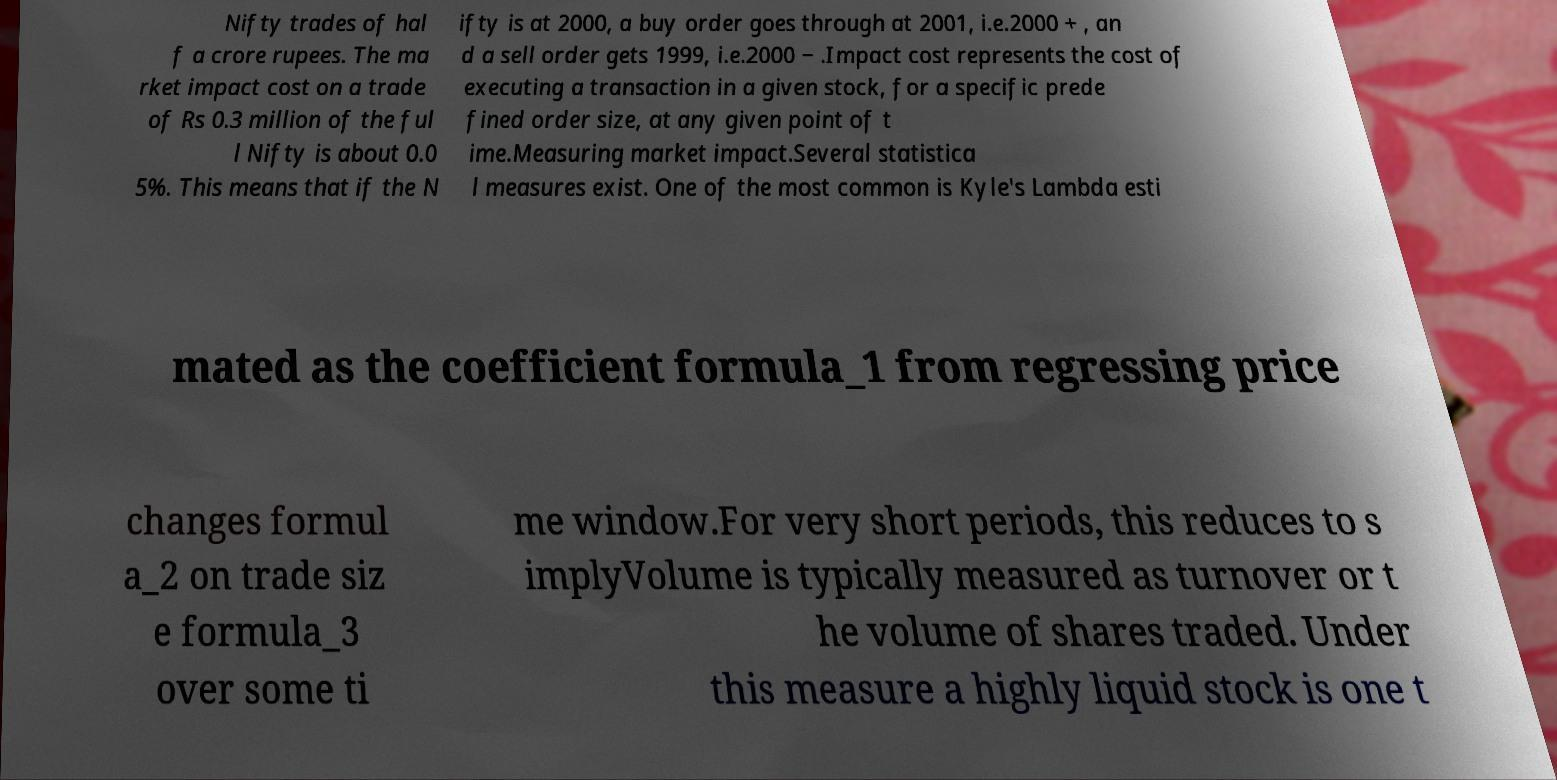Could you extract and type out the text from this image? Nifty trades of hal f a crore rupees. The ma rket impact cost on a trade of Rs 0.3 million of the ful l Nifty is about 0.0 5%. This means that if the N ifty is at 2000, a buy order goes through at 2001, i.e.2000 + , an d a sell order gets 1999, i.e.2000 − .Impact cost represents the cost of executing a transaction in a given stock, for a specific prede fined order size, at any given point of t ime.Measuring market impact.Several statistica l measures exist. One of the most common is Kyle's Lambda esti mated as the coefficient formula_1 from regressing price changes formul a_2 on trade siz e formula_3 over some ti me window.For very short periods, this reduces to s implyVolume is typically measured as turnover or t he volume of shares traded. Under this measure a highly liquid stock is one t 